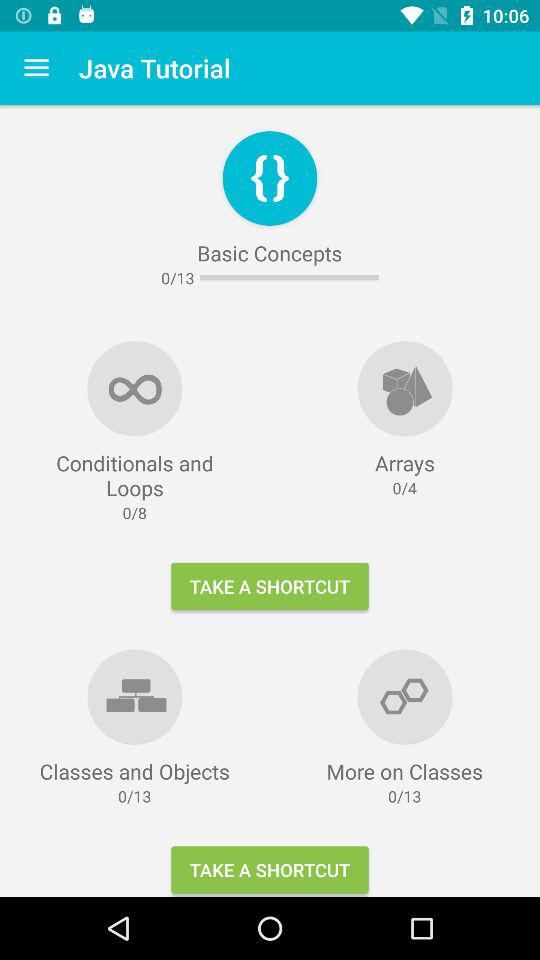How many modules in total are there in "Conditionals and Loops" in "Java Tutorial"? There are 8 modules in total in "Conditionals and Loops" in "Java Tutorial". 